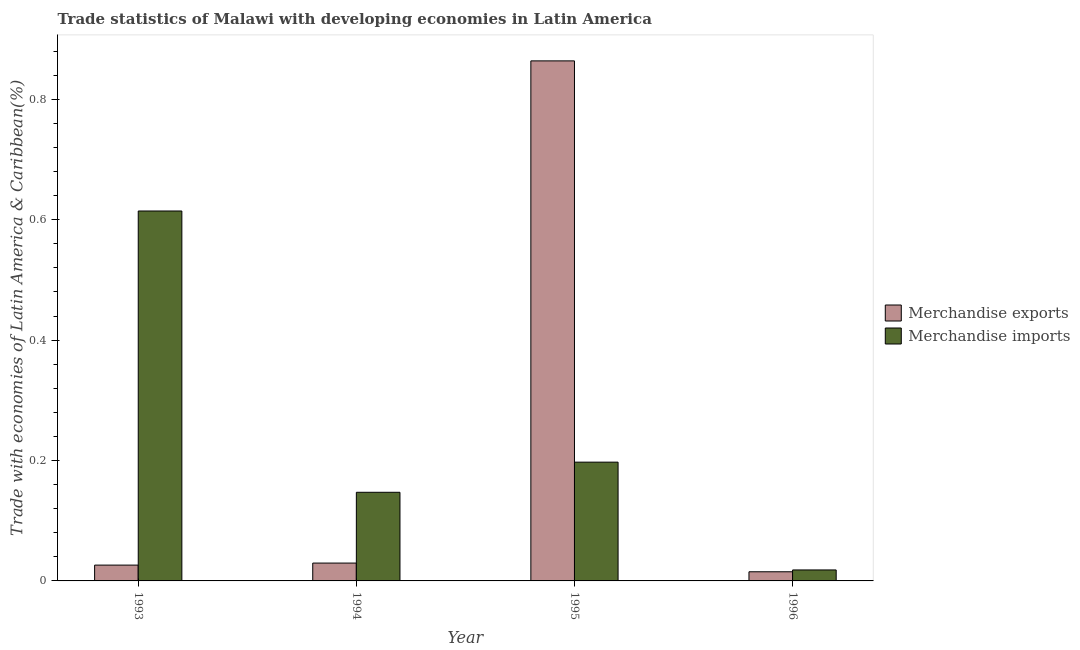How many different coloured bars are there?
Offer a very short reply. 2. How many bars are there on the 2nd tick from the left?
Your response must be concise. 2. What is the label of the 4th group of bars from the left?
Keep it short and to the point. 1996. What is the merchandise exports in 1993?
Your response must be concise. 0.03. Across all years, what is the maximum merchandise imports?
Provide a succinct answer. 0.61. Across all years, what is the minimum merchandise imports?
Provide a short and direct response. 0.02. In which year was the merchandise imports minimum?
Offer a terse response. 1996. What is the total merchandise imports in the graph?
Your answer should be very brief. 0.98. What is the difference between the merchandise exports in 1993 and that in 1996?
Your response must be concise. 0.01. What is the difference between the merchandise exports in 1994 and the merchandise imports in 1995?
Offer a very short reply. -0.83. What is the average merchandise imports per year?
Your answer should be compact. 0.24. In the year 1996, what is the difference between the merchandise imports and merchandise exports?
Your response must be concise. 0. What is the ratio of the merchandise imports in 1993 to that in 1996?
Your answer should be very brief. 33.71. Is the difference between the merchandise imports in 1994 and 1995 greater than the difference between the merchandise exports in 1994 and 1995?
Provide a succinct answer. No. What is the difference between the highest and the second highest merchandise exports?
Your answer should be compact. 0.83. What is the difference between the highest and the lowest merchandise imports?
Offer a terse response. 0.6. Is the sum of the merchandise imports in 1995 and 1996 greater than the maximum merchandise exports across all years?
Keep it short and to the point. No. What does the 1st bar from the left in 1994 represents?
Ensure brevity in your answer.  Merchandise exports. What does the 2nd bar from the right in 1993 represents?
Provide a succinct answer. Merchandise exports. How many bars are there?
Keep it short and to the point. 8. Are the values on the major ticks of Y-axis written in scientific E-notation?
Your answer should be very brief. No. Does the graph contain any zero values?
Provide a succinct answer. No. How many legend labels are there?
Offer a very short reply. 2. What is the title of the graph?
Offer a very short reply. Trade statistics of Malawi with developing economies in Latin America. What is the label or title of the Y-axis?
Your answer should be very brief. Trade with economies of Latin America & Caribbean(%). What is the Trade with economies of Latin America & Caribbean(%) of Merchandise exports in 1993?
Ensure brevity in your answer.  0.03. What is the Trade with economies of Latin America & Caribbean(%) in Merchandise imports in 1993?
Make the answer very short. 0.61. What is the Trade with economies of Latin America & Caribbean(%) in Merchandise exports in 1994?
Make the answer very short. 0.03. What is the Trade with economies of Latin America & Caribbean(%) of Merchandise imports in 1994?
Keep it short and to the point. 0.15. What is the Trade with economies of Latin America & Caribbean(%) in Merchandise exports in 1995?
Your response must be concise. 0.86. What is the Trade with economies of Latin America & Caribbean(%) in Merchandise imports in 1995?
Ensure brevity in your answer.  0.2. What is the Trade with economies of Latin America & Caribbean(%) of Merchandise exports in 1996?
Offer a very short reply. 0.02. What is the Trade with economies of Latin America & Caribbean(%) of Merchandise imports in 1996?
Provide a short and direct response. 0.02. Across all years, what is the maximum Trade with economies of Latin America & Caribbean(%) of Merchandise exports?
Keep it short and to the point. 0.86. Across all years, what is the maximum Trade with economies of Latin America & Caribbean(%) in Merchandise imports?
Offer a very short reply. 0.61. Across all years, what is the minimum Trade with economies of Latin America & Caribbean(%) of Merchandise exports?
Provide a succinct answer. 0.02. Across all years, what is the minimum Trade with economies of Latin America & Caribbean(%) of Merchandise imports?
Make the answer very short. 0.02. What is the total Trade with economies of Latin America & Caribbean(%) of Merchandise exports in the graph?
Make the answer very short. 0.93. What is the total Trade with economies of Latin America & Caribbean(%) of Merchandise imports in the graph?
Your answer should be compact. 0.98. What is the difference between the Trade with economies of Latin America & Caribbean(%) of Merchandise exports in 1993 and that in 1994?
Your response must be concise. -0. What is the difference between the Trade with economies of Latin America & Caribbean(%) of Merchandise imports in 1993 and that in 1994?
Give a very brief answer. 0.47. What is the difference between the Trade with economies of Latin America & Caribbean(%) in Merchandise exports in 1993 and that in 1995?
Give a very brief answer. -0.84. What is the difference between the Trade with economies of Latin America & Caribbean(%) in Merchandise imports in 1993 and that in 1995?
Keep it short and to the point. 0.42. What is the difference between the Trade with economies of Latin America & Caribbean(%) in Merchandise exports in 1993 and that in 1996?
Keep it short and to the point. 0.01. What is the difference between the Trade with economies of Latin America & Caribbean(%) in Merchandise imports in 1993 and that in 1996?
Your answer should be very brief. 0.6. What is the difference between the Trade with economies of Latin America & Caribbean(%) in Merchandise exports in 1994 and that in 1995?
Your answer should be compact. -0.83. What is the difference between the Trade with economies of Latin America & Caribbean(%) of Merchandise imports in 1994 and that in 1995?
Your response must be concise. -0.05. What is the difference between the Trade with economies of Latin America & Caribbean(%) of Merchandise exports in 1994 and that in 1996?
Make the answer very short. 0.01. What is the difference between the Trade with economies of Latin America & Caribbean(%) in Merchandise imports in 1994 and that in 1996?
Ensure brevity in your answer.  0.13. What is the difference between the Trade with economies of Latin America & Caribbean(%) in Merchandise exports in 1995 and that in 1996?
Make the answer very short. 0.85. What is the difference between the Trade with economies of Latin America & Caribbean(%) of Merchandise imports in 1995 and that in 1996?
Keep it short and to the point. 0.18. What is the difference between the Trade with economies of Latin America & Caribbean(%) in Merchandise exports in 1993 and the Trade with economies of Latin America & Caribbean(%) in Merchandise imports in 1994?
Offer a very short reply. -0.12. What is the difference between the Trade with economies of Latin America & Caribbean(%) of Merchandise exports in 1993 and the Trade with economies of Latin America & Caribbean(%) of Merchandise imports in 1995?
Provide a short and direct response. -0.17. What is the difference between the Trade with economies of Latin America & Caribbean(%) of Merchandise exports in 1993 and the Trade with economies of Latin America & Caribbean(%) of Merchandise imports in 1996?
Provide a succinct answer. 0.01. What is the difference between the Trade with economies of Latin America & Caribbean(%) in Merchandise exports in 1994 and the Trade with economies of Latin America & Caribbean(%) in Merchandise imports in 1995?
Your answer should be compact. -0.17. What is the difference between the Trade with economies of Latin America & Caribbean(%) of Merchandise exports in 1994 and the Trade with economies of Latin America & Caribbean(%) of Merchandise imports in 1996?
Your answer should be compact. 0.01. What is the difference between the Trade with economies of Latin America & Caribbean(%) in Merchandise exports in 1995 and the Trade with economies of Latin America & Caribbean(%) in Merchandise imports in 1996?
Keep it short and to the point. 0.85. What is the average Trade with economies of Latin America & Caribbean(%) in Merchandise exports per year?
Provide a succinct answer. 0.23. What is the average Trade with economies of Latin America & Caribbean(%) of Merchandise imports per year?
Your response must be concise. 0.24. In the year 1993, what is the difference between the Trade with economies of Latin America & Caribbean(%) of Merchandise exports and Trade with economies of Latin America & Caribbean(%) of Merchandise imports?
Provide a succinct answer. -0.59. In the year 1994, what is the difference between the Trade with economies of Latin America & Caribbean(%) of Merchandise exports and Trade with economies of Latin America & Caribbean(%) of Merchandise imports?
Give a very brief answer. -0.12. In the year 1995, what is the difference between the Trade with economies of Latin America & Caribbean(%) in Merchandise exports and Trade with economies of Latin America & Caribbean(%) in Merchandise imports?
Make the answer very short. 0.67. In the year 1996, what is the difference between the Trade with economies of Latin America & Caribbean(%) of Merchandise exports and Trade with economies of Latin America & Caribbean(%) of Merchandise imports?
Your answer should be very brief. -0. What is the ratio of the Trade with economies of Latin America & Caribbean(%) in Merchandise exports in 1993 to that in 1994?
Give a very brief answer. 0.89. What is the ratio of the Trade with economies of Latin America & Caribbean(%) in Merchandise imports in 1993 to that in 1994?
Your response must be concise. 4.17. What is the ratio of the Trade with economies of Latin America & Caribbean(%) in Merchandise exports in 1993 to that in 1995?
Provide a short and direct response. 0.03. What is the ratio of the Trade with economies of Latin America & Caribbean(%) in Merchandise imports in 1993 to that in 1995?
Your answer should be compact. 3.11. What is the ratio of the Trade with economies of Latin America & Caribbean(%) of Merchandise exports in 1993 to that in 1996?
Your answer should be compact. 1.73. What is the ratio of the Trade with economies of Latin America & Caribbean(%) in Merchandise imports in 1993 to that in 1996?
Keep it short and to the point. 33.71. What is the ratio of the Trade with economies of Latin America & Caribbean(%) in Merchandise exports in 1994 to that in 1995?
Provide a short and direct response. 0.03. What is the ratio of the Trade with economies of Latin America & Caribbean(%) of Merchandise imports in 1994 to that in 1995?
Your answer should be very brief. 0.75. What is the ratio of the Trade with economies of Latin America & Caribbean(%) in Merchandise exports in 1994 to that in 1996?
Your answer should be very brief. 1.95. What is the ratio of the Trade with economies of Latin America & Caribbean(%) in Merchandise imports in 1994 to that in 1996?
Keep it short and to the point. 8.08. What is the ratio of the Trade with economies of Latin America & Caribbean(%) of Merchandise exports in 1995 to that in 1996?
Give a very brief answer. 56.86. What is the ratio of the Trade with economies of Latin America & Caribbean(%) of Merchandise imports in 1995 to that in 1996?
Offer a very short reply. 10.82. What is the difference between the highest and the second highest Trade with economies of Latin America & Caribbean(%) of Merchandise exports?
Make the answer very short. 0.83. What is the difference between the highest and the second highest Trade with economies of Latin America & Caribbean(%) in Merchandise imports?
Make the answer very short. 0.42. What is the difference between the highest and the lowest Trade with economies of Latin America & Caribbean(%) of Merchandise exports?
Make the answer very short. 0.85. What is the difference between the highest and the lowest Trade with economies of Latin America & Caribbean(%) of Merchandise imports?
Offer a terse response. 0.6. 